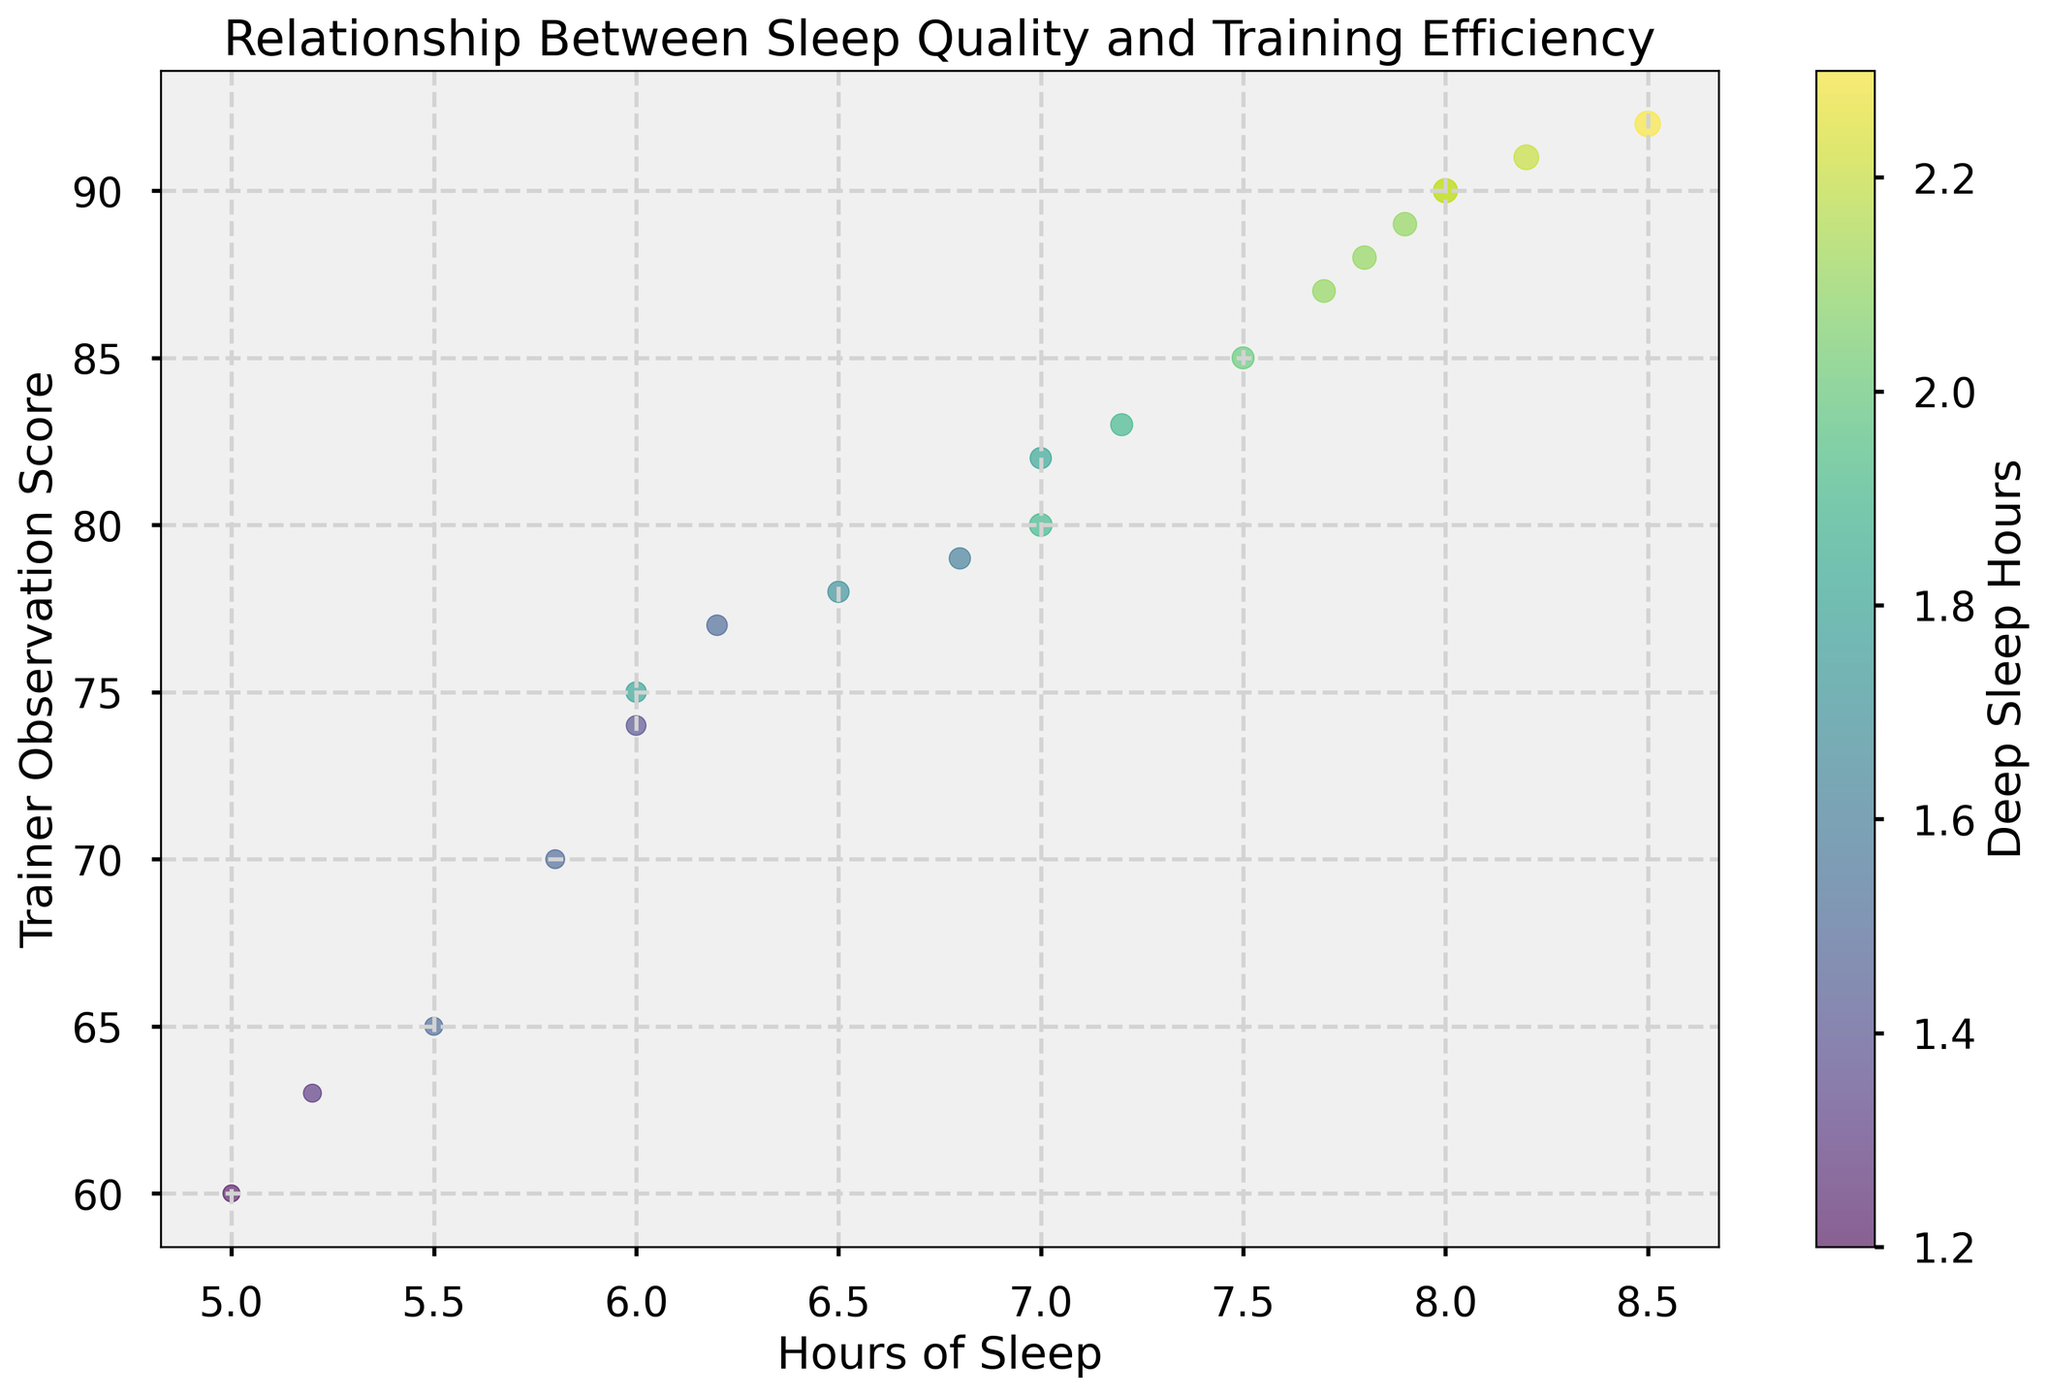What is the range of Trainer Observation Scores? Look at the y-axis values. The lowest score is around 60 and the highest is around 92.
Answer: 60-92 Which data point has the highest REM Sleep Hours and what is its corresponding Trainer Observation Score? Look at the sizes of the circles for REM Sleep Hours and identify the largest circle. It corresponds to the highest REM Sleep Hours, which falls at the data point with a Trainer Observation Score around 92.
Answer: 92 Is there a noticeable trend between hours of sleep and the Trainer Observation Score? Observe the scatter plot for any trend. As Hours of Sleep increases, the Trainer Observation Score generally increases, suggesting a positive correlation.
Answer: Yes, positive correlation How does Deep Sleep Hours relate to the Trainer Observation Score? Notice the color gradient in the scatter plot that represents Deep Sleep Hours. Darker colors (more Deep Sleep) are generally associated with higher Trainer Observation Scores.
Answer: More Deep Sleep, higher score Do any data points with less than 6 hours of sleep have a Trainer Observation Score above 80? Identify the circles to the left of 6 on the x-axis and check their corresponding y-values. None of them have a Trainer Observation Score above 80.
Answer: No How many data points are there with more than 8 hours of sleep? Count the number of data points to the right of 8 on the x-axis. There are two data points with more than 8 hours of sleep.
Answer: 2 Which data point has the lowest Trainer Observation Score and what are its Hours of Sleep and Deep Sleep Hours? Identify the data point at the lowest position on the y-axis. The lowest Trainer Observation Score is around 60, with approximately 5 hours of sleep and about 1.2 Deep Sleep Hours (light color).
Answer: Approx. 5 hours sleep, 1.2 Deep Sleep Hours What is the average Trainer Observation Score for data points with more than 7 hours of sleep? First, identify the data points with more than 7 hours of sleep. Then calculate the average of their corresponding Trainer Observation Scores: (85 + 90 + 88 + 92 + 83 + 87 + 89 + 90) / 8 = 704 / 8.
Answer: 88 Compare the Trainer Observation Scores for data points with 7 hours of sleep to those with 6 hours of sleep. Identify the data points for 7 hours (scores: 80, 82) and 6 hours (scores: 75, 74). Compare their averages: (80 + 82) / 2 = 81 for 7 hours, (75 + 74) / 2 = 74.5 for 6 hours; 7 hours has higher scores.
Answer: Higher for 7 hours How does the variation in REM Sleep Hours affect the scoring as judged by the trainer? Observe the sizes of the circles, which represent REM Sleep Hours, against the y-axis values. Generally, larger circles (more REM Sleep) tend to correspond to higher Trainer Observation Scores.
Answer: More REM Sleep, higher score 